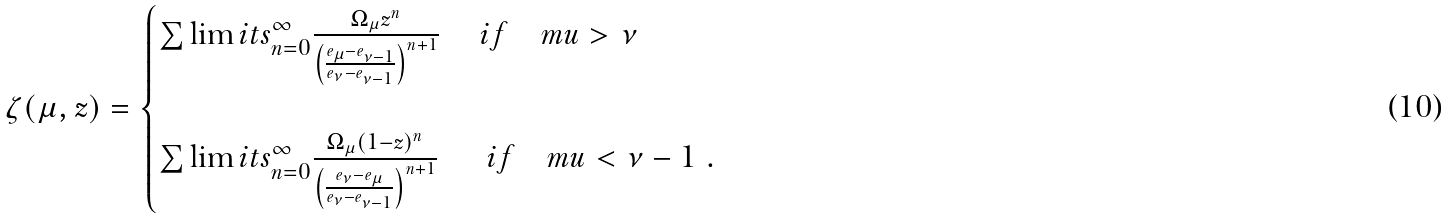<formula> <loc_0><loc_0><loc_500><loc_500>\zeta ( \mu , z ) = \begin{cases} \sum \lim i t s _ { n = 0 } ^ { \infty } \frac { \Omega _ { \mu } z ^ { n } } { \left ( \frac { e _ { \mu } - e _ { \nu - 1 } } { e _ { \nu } - e _ { \nu - 1 } } \right ) ^ { n + 1 } } \ \quad i f \quad m u > \nu \\ \\ \sum \lim i t s _ { n = 0 } ^ { \infty } \frac { \Omega _ { \mu } ( 1 - z ) ^ { n } } { \left ( \frac { e _ { \nu } - e _ { \mu } } { e _ { \nu } - e _ { \nu - 1 } } \right ) ^ { n + 1 } } \quad \ \ i f \quad m u < \nu - 1 \ . \end{cases}</formula> 